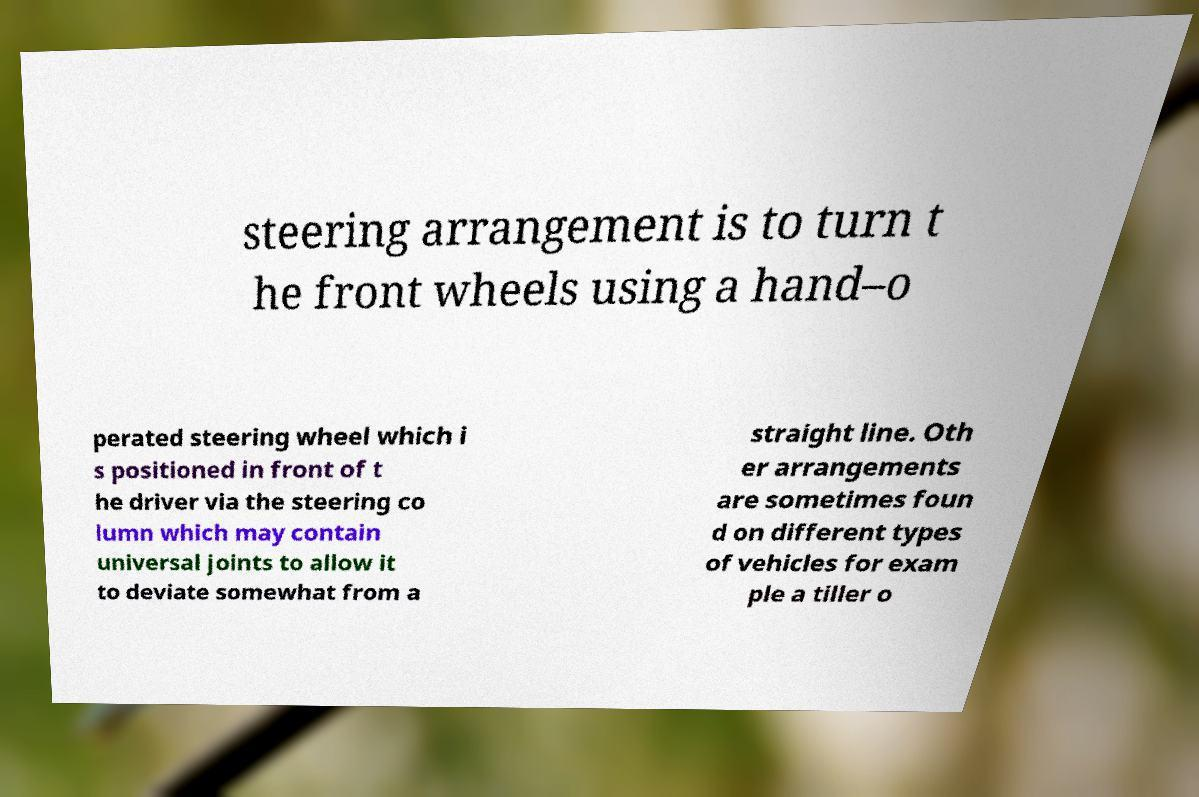Could you extract and type out the text from this image? steering arrangement is to turn t he front wheels using a hand–o perated steering wheel which i s positioned in front of t he driver via the steering co lumn which may contain universal joints to allow it to deviate somewhat from a straight line. Oth er arrangements are sometimes foun d on different types of vehicles for exam ple a tiller o 